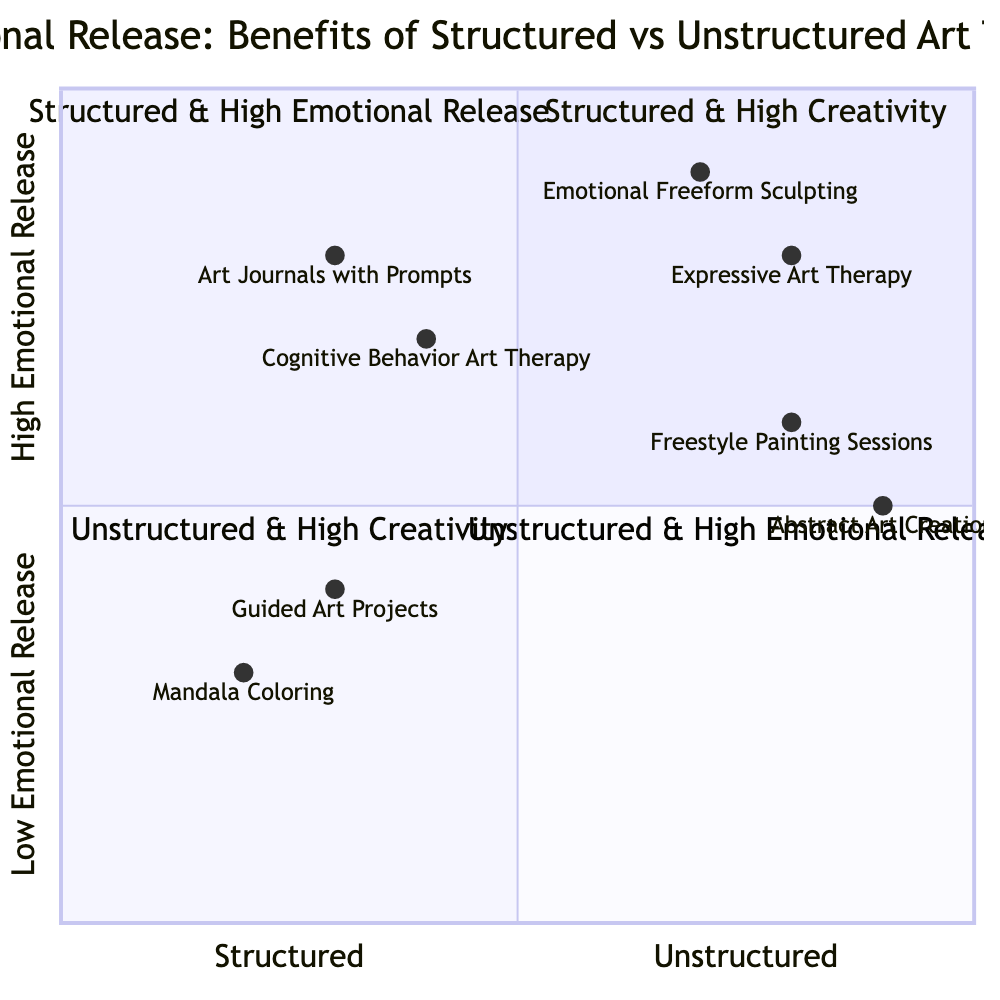What are the two entities in the quadrant "Unstructured & High Emotional Release"? In the quadrant titled "Unstructured & High Emotional Release," the diagram lists two entities: "Emotional Freeform Sculpting" and "Expressive Art Therapy." Both are found in the bottom right quadrant of the chart, indicating high emotional release.
Answer: Emotional Freeform Sculpting, Expressive Art Therapy Which approach is associated with "Boosts Problem-Solving Skills"? The entity "Guided Art Projects" listed in the "Structured & High Creativity" quadrant is associated with the benefit of boosting problem-solving skills. This is found in the upper left quadrant of the chart.
Answer: Guided Art Projects How many entities are represented in the quadrant titled "Structured & High Emotional Release"? There are two entities represented in the quadrant "Structured & High Emotional Release": "Cognitive Behavior Art Therapy" and "Art Journals with Prompts." Therefore, the number of entities is 2.
Answer: 2 Which quadrant includes "Freestyle Painting Sessions"? The entity "Freestyle Painting Sessions" is found in the quadrant "Unstructured & High Creativity." It is positioned in the bottom left quadrant of the chart, which focuses on high creativity without structure.
Answer: Unstructured & High Creativity What is the relationship between "Cognitive Behavior Art Therapy" and emotional regulation? "Cognitive Behavior Art Therapy" is listed as enhancing emotional regulation, and it is categorized in the "Structured & High Emotional Release" quadrant. Therefore, its benefit directly relates to emotional regulation.
Answer: Enhances emotional regulation Which approach has the highest level of creativity based on this diagram? The approach with the highest level of creativity is "Abstract Art Creation," found in the "Unstructured & High Creativity" quadrant. It is positioned further right in relation to other entities in the chart.
Answer: Abstract Art Creation What is the unique feature of the quadrant "Structured & High Creativity" compared to others? The unique feature of the "Structured & High Creativity" quadrant is that it combines a structured approach with high levels of creativity, specifically represented by entities like "Mandala Coloring" and "Guided Art Projects," which enhance cognitive functioning and boost problem-solving skills.
Answer: Structured approach with high creativity What emotional benefit does "Art Journals with Prompts" provide? "Art Journals with Prompts," found in the "Structured & High Emotional Release" quadrant, provides the emotional benefit of reducing anxiety, indicating a clear focus on emotional release within a structured format.
Answer: Reduces anxiety 